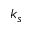<formula> <loc_0><loc_0><loc_500><loc_500>k _ { s }</formula> 